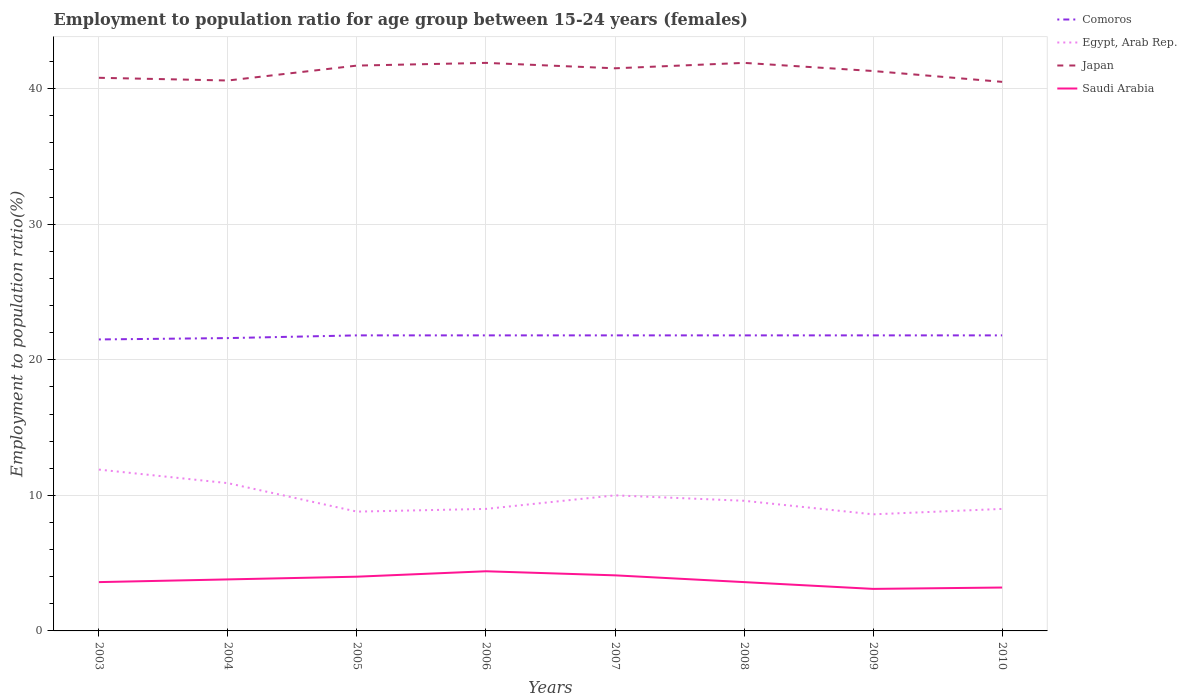Is the number of lines equal to the number of legend labels?
Your answer should be very brief. Yes. Across all years, what is the maximum employment to population ratio in Egypt, Arab Rep.?
Keep it short and to the point. 8.6. In which year was the employment to population ratio in Comoros maximum?
Your response must be concise. 2003. What is the difference between the highest and the second highest employment to population ratio in Egypt, Arab Rep.?
Keep it short and to the point. 3.3. What is the difference between the highest and the lowest employment to population ratio in Saudi Arabia?
Provide a short and direct response. 4. Is the employment to population ratio in Saudi Arabia strictly greater than the employment to population ratio in Japan over the years?
Offer a very short reply. Yes. How many lines are there?
Your response must be concise. 4. Does the graph contain any zero values?
Offer a very short reply. No. How many legend labels are there?
Your answer should be compact. 4. What is the title of the graph?
Your answer should be compact. Employment to population ratio for age group between 15-24 years (females). What is the Employment to population ratio(%) in Comoros in 2003?
Keep it short and to the point. 21.5. What is the Employment to population ratio(%) in Egypt, Arab Rep. in 2003?
Make the answer very short. 11.9. What is the Employment to population ratio(%) in Japan in 2003?
Your answer should be compact. 40.8. What is the Employment to population ratio(%) in Saudi Arabia in 2003?
Keep it short and to the point. 3.6. What is the Employment to population ratio(%) in Comoros in 2004?
Keep it short and to the point. 21.6. What is the Employment to population ratio(%) of Egypt, Arab Rep. in 2004?
Offer a terse response. 10.9. What is the Employment to population ratio(%) in Japan in 2004?
Offer a very short reply. 40.6. What is the Employment to population ratio(%) in Saudi Arabia in 2004?
Provide a short and direct response. 3.8. What is the Employment to population ratio(%) of Comoros in 2005?
Offer a very short reply. 21.8. What is the Employment to population ratio(%) of Egypt, Arab Rep. in 2005?
Give a very brief answer. 8.8. What is the Employment to population ratio(%) of Japan in 2005?
Ensure brevity in your answer.  41.7. What is the Employment to population ratio(%) in Comoros in 2006?
Keep it short and to the point. 21.8. What is the Employment to population ratio(%) in Egypt, Arab Rep. in 2006?
Offer a very short reply. 9. What is the Employment to population ratio(%) in Japan in 2006?
Your response must be concise. 41.9. What is the Employment to population ratio(%) of Saudi Arabia in 2006?
Offer a terse response. 4.4. What is the Employment to population ratio(%) of Comoros in 2007?
Keep it short and to the point. 21.8. What is the Employment to population ratio(%) in Japan in 2007?
Keep it short and to the point. 41.5. What is the Employment to population ratio(%) in Saudi Arabia in 2007?
Your answer should be very brief. 4.1. What is the Employment to population ratio(%) of Comoros in 2008?
Your answer should be very brief. 21.8. What is the Employment to population ratio(%) of Egypt, Arab Rep. in 2008?
Offer a very short reply. 9.6. What is the Employment to population ratio(%) in Japan in 2008?
Your answer should be compact. 41.9. What is the Employment to population ratio(%) of Saudi Arabia in 2008?
Give a very brief answer. 3.6. What is the Employment to population ratio(%) of Comoros in 2009?
Provide a short and direct response. 21.8. What is the Employment to population ratio(%) of Egypt, Arab Rep. in 2009?
Offer a very short reply. 8.6. What is the Employment to population ratio(%) of Japan in 2009?
Offer a very short reply. 41.3. What is the Employment to population ratio(%) in Saudi Arabia in 2009?
Keep it short and to the point. 3.1. What is the Employment to population ratio(%) of Comoros in 2010?
Your response must be concise. 21.8. What is the Employment to population ratio(%) of Japan in 2010?
Offer a very short reply. 40.5. What is the Employment to population ratio(%) of Saudi Arabia in 2010?
Offer a very short reply. 3.2. Across all years, what is the maximum Employment to population ratio(%) in Comoros?
Your response must be concise. 21.8. Across all years, what is the maximum Employment to population ratio(%) in Egypt, Arab Rep.?
Provide a succinct answer. 11.9. Across all years, what is the maximum Employment to population ratio(%) in Japan?
Provide a short and direct response. 41.9. Across all years, what is the maximum Employment to population ratio(%) in Saudi Arabia?
Offer a very short reply. 4.4. Across all years, what is the minimum Employment to population ratio(%) in Comoros?
Offer a very short reply. 21.5. Across all years, what is the minimum Employment to population ratio(%) of Egypt, Arab Rep.?
Provide a succinct answer. 8.6. Across all years, what is the minimum Employment to population ratio(%) of Japan?
Your response must be concise. 40.5. Across all years, what is the minimum Employment to population ratio(%) of Saudi Arabia?
Ensure brevity in your answer.  3.1. What is the total Employment to population ratio(%) in Comoros in the graph?
Provide a succinct answer. 173.9. What is the total Employment to population ratio(%) in Egypt, Arab Rep. in the graph?
Offer a terse response. 77.8. What is the total Employment to population ratio(%) in Japan in the graph?
Give a very brief answer. 330.2. What is the total Employment to population ratio(%) of Saudi Arabia in the graph?
Offer a terse response. 29.8. What is the difference between the Employment to population ratio(%) of Comoros in 2003 and that in 2004?
Offer a terse response. -0.1. What is the difference between the Employment to population ratio(%) of Japan in 2003 and that in 2004?
Offer a very short reply. 0.2. What is the difference between the Employment to population ratio(%) of Saudi Arabia in 2003 and that in 2004?
Ensure brevity in your answer.  -0.2. What is the difference between the Employment to population ratio(%) in Comoros in 2003 and that in 2006?
Your response must be concise. -0.3. What is the difference between the Employment to population ratio(%) in Saudi Arabia in 2003 and that in 2006?
Provide a succinct answer. -0.8. What is the difference between the Employment to population ratio(%) of Comoros in 2003 and that in 2007?
Keep it short and to the point. -0.3. What is the difference between the Employment to population ratio(%) of Egypt, Arab Rep. in 2003 and that in 2007?
Give a very brief answer. 1.9. What is the difference between the Employment to population ratio(%) of Saudi Arabia in 2003 and that in 2007?
Provide a succinct answer. -0.5. What is the difference between the Employment to population ratio(%) of Comoros in 2003 and that in 2008?
Your answer should be compact. -0.3. What is the difference between the Employment to population ratio(%) in Egypt, Arab Rep. in 2003 and that in 2008?
Ensure brevity in your answer.  2.3. What is the difference between the Employment to population ratio(%) in Japan in 2003 and that in 2010?
Your response must be concise. 0.3. What is the difference between the Employment to population ratio(%) in Saudi Arabia in 2003 and that in 2010?
Provide a short and direct response. 0.4. What is the difference between the Employment to population ratio(%) in Japan in 2004 and that in 2005?
Your answer should be compact. -1.1. What is the difference between the Employment to population ratio(%) of Comoros in 2004 and that in 2006?
Keep it short and to the point. -0.2. What is the difference between the Employment to population ratio(%) of Egypt, Arab Rep. in 2004 and that in 2006?
Provide a short and direct response. 1.9. What is the difference between the Employment to population ratio(%) in Japan in 2004 and that in 2006?
Provide a succinct answer. -1.3. What is the difference between the Employment to population ratio(%) of Comoros in 2004 and that in 2008?
Provide a short and direct response. -0.2. What is the difference between the Employment to population ratio(%) in Saudi Arabia in 2004 and that in 2008?
Make the answer very short. 0.2. What is the difference between the Employment to population ratio(%) in Comoros in 2004 and that in 2009?
Your response must be concise. -0.2. What is the difference between the Employment to population ratio(%) in Japan in 2004 and that in 2009?
Your response must be concise. -0.7. What is the difference between the Employment to population ratio(%) in Saudi Arabia in 2004 and that in 2009?
Your answer should be compact. 0.7. What is the difference between the Employment to population ratio(%) of Egypt, Arab Rep. in 2004 and that in 2010?
Give a very brief answer. 1.9. What is the difference between the Employment to population ratio(%) in Japan in 2004 and that in 2010?
Ensure brevity in your answer.  0.1. What is the difference between the Employment to population ratio(%) in Saudi Arabia in 2004 and that in 2010?
Provide a short and direct response. 0.6. What is the difference between the Employment to population ratio(%) in Egypt, Arab Rep. in 2005 and that in 2006?
Give a very brief answer. -0.2. What is the difference between the Employment to population ratio(%) of Japan in 2005 and that in 2006?
Make the answer very short. -0.2. What is the difference between the Employment to population ratio(%) of Japan in 2005 and that in 2007?
Keep it short and to the point. 0.2. What is the difference between the Employment to population ratio(%) of Comoros in 2005 and that in 2008?
Give a very brief answer. 0. What is the difference between the Employment to population ratio(%) in Egypt, Arab Rep. in 2005 and that in 2008?
Keep it short and to the point. -0.8. What is the difference between the Employment to population ratio(%) of Comoros in 2005 and that in 2009?
Keep it short and to the point. 0. What is the difference between the Employment to population ratio(%) of Saudi Arabia in 2005 and that in 2009?
Your answer should be compact. 0.9. What is the difference between the Employment to population ratio(%) in Comoros in 2005 and that in 2010?
Your response must be concise. 0. What is the difference between the Employment to population ratio(%) of Egypt, Arab Rep. in 2005 and that in 2010?
Make the answer very short. -0.2. What is the difference between the Employment to population ratio(%) of Japan in 2005 and that in 2010?
Offer a terse response. 1.2. What is the difference between the Employment to population ratio(%) in Japan in 2006 and that in 2007?
Provide a short and direct response. 0.4. What is the difference between the Employment to population ratio(%) of Saudi Arabia in 2006 and that in 2007?
Make the answer very short. 0.3. What is the difference between the Employment to population ratio(%) of Saudi Arabia in 2006 and that in 2008?
Give a very brief answer. 0.8. What is the difference between the Employment to population ratio(%) of Egypt, Arab Rep. in 2006 and that in 2010?
Give a very brief answer. 0. What is the difference between the Employment to population ratio(%) in Comoros in 2007 and that in 2008?
Keep it short and to the point. 0. What is the difference between the Employment to population ratio(%) in Egypt, Arab Rep. in 2007 and that in 2008?
Your response must be concise. 0.4. What is the difference between the Employment to population ratio(%) of Egypt, Arab Rep. in 2007 and that in 2009?
Offer a very short reply. 1.4. What is the difference between the Employment to population ratio(%) of Saudi Arabia in 2007 and that in 2009?
Keep it short and to the point. 1. What is the difference between the Employment to population ratio(%) of Japan in 2007 and that in 2010?
Make the answer very short. 1. What is the difference between the Employment to population ratio(%) in Comoros in 2008 and that in 2009?
Keep it short and to the point. 0. What is the difference between the Employment to population ratio(%) of Saudi Arabia in 2008 and that in 2009?
Keep it short and to the point. 0.5. What is the difference between the Employment to population ratio(%) of Comoros in 2008 and that in 2010?
Provide a succinct answer. 0. What is the difference between the Employment to population ratio(%) in Egypt, Arab Rep. in 2009 and that in 2010?
Your answer should be very brief. -0.4. What is the difference between the Employment to population ratio(%) of Japan in 2009 and that in 2010?
Your answer should be very brief. 0.8. What is the difference between the Employment to population ratio(%) of Comoros in 2003 and the Employment to population ratio(%) of Egypt, Arab Rep. in 2004?
Ensure brevity in your answer.  10.6. What is the difference between the Employment to population ratio(%) in Comoros in 2003 and the Employment to population ratio(%) in Japan in 2004?
Offer a terse response. -19.1. What is the difference between the Employment to population ratio(%) of Egypt, Arab Rep. in 2003 and the Employment to population ratio(%) of Japan in 2004?
Keep it short and to the point. -28.7. What is the difference between the Employment to population ratio(%) in Comoros in 2003 and the Employment to population ratio(%) in Egypt, Arab Rep. in 2005?
Your response must be concise. 12.7. What is the difference between the Employment to population ratio(%) of Comoros in 2003 and the Employment to population ratio(%) of Japan in 2005?
Keep it short and to the point. -20.2. What is the difference between the Employment to population ratio(%) in Egypt, Arab Rep. in 2003 and the Employment to population ratio(%) in Japan in 2005?
Keep it short and to the point. -29.8. What is the difference between the Employment to population ratio(%) of Japan in 2003 and the Employment to population ratio(%) of Saudi Arabia in 2005?
Make the answer very short. 36.8. What is the difference between the Employment to population ratio(%) of Comoros in 2003 and the Employment to population ratio(%) of Japan in 2006?
Provide a succinct answer. -20.4. What is the difference between the Employment to population ratio(%) in Japan in 2003 and the Employment to population ratio(%) in Saudi Arabia in 2006?
Your answer should be very brief. 36.4. What is the difference between the Employment to population ratio(%) of Comoros in 2003 and the Employment to population ratio(%) of Egypt, Arab Rep. in 2007?
Keep it short and to the point. 11.5. What is the difference between the Employment to population ratio(%) of Comoros in 2003 and the Employment to population ratio(%) of Japan in 2007?
Give a very brief answer. -20. What is the difference between the Employment to population ratio(%) of Egypt, Arab Rep. in 2003 and the Employment to population ratio(%) of Japan in 2007?
Provide a succinct answer. -29.6. What is the difference between the Employment to population ratio(%) in Egypt, Arab Rep. in 2003 and the Employment to population ratio(%) in Saudi Arabia in 2007?
Ensure brevity in your answer.  7.8. What is the difference between the Employment to population ratio(%) in Japan in 2003 and the Employment to population ratio(%) in Saudi Arabia in 2007?
Ensure brevity in your answer.  36.7. What is the difference between the Employment to population ratio(%) in Comoros in 2003 and the Employment to population ratio(%) in Japan in 2008?
Keep it short and to the point. -20.4. What is the difference between the Employment to population ratio(%) of Egypt, Arab Rep. in 2003 and the Employment to population ratio(%) of Japan in 2008?
Ensure brevity in your answer.  -30. What is the difference between the Employment to population ratio(%) of Japan in 2003 and the Employment to population ratio(%) of Saudi Arabia in 2008?
Your answer should be very brief. 37.2. What is the difference between the Employment to population ratio(%) of Comoros in 2003 and the Employment to population ratio(%) of Egypt, Arab Rep. in 2009?
Ensure brevity in your answer.  12.9. What is the difference between the Employment to population ratio(%) of Comoros in 2003 and the Employment to population ratio(%) of Japan in 2009?
Offer a very short reply. -19.8. What is the difference between the Employment to population ratio(%) of Egypt, Arab Rep. in 2003 and the Employment to population ratio(%) of Japan in 2009?
Your answer should be compact. -29.4. What is the difference between the Employment to population ratio(%) of Japan in 2003 and the Employment to population ratio(%) of Saudi Arabia in 2009?
Your response must be concise. 37.7. What is the difference between the Employment to population ratio(%) in Comoros in 2003 and the Employment to population ratio(%) in Egypt, Arab Rep. in 2010?
Provide a succinct answer. 12.5. What is the difference between the Employment to population ratio(%) of Comoros in 2003 and the Employment to population ratio(%) of Japan in 2010?
Keep it short and to the point. -19. What is the difference between the Employment to population ratio(%) of Comoros in 2003 and the Employment to population ratio(%) of Saudi Arabia in 2010?
Ensure brevity in your answer.  18.3. What is the difference between the Employment to population ratio(%) of Egypt, Arab Rep. in 2003 and the Employment to population ratio(%) of Japan in 2010?
Your answer should be compact. -28.6. What is the difference between the Employment to population ratio(%) in Japan in 2003 and the Employment to population ratio(%) in Saudi Arabia in 2010?
Your response must be concise. 37.6. What is the difference between the Employment to population ratio(%) of Comoros in 2004 and the Employment to population ratio(%) of Japan in 2005?
Keep it short and to the point. -20.1. What is the difference between the Employment to population ratio(%) of Egypt, Arab Rep. in 2004 and the Employment to population ratio(%) of Japan in 2005?
Keep it short and to the point. -30.8. What is the difference between the Employment to population ratio(%) of Egypt, Arab Rep. in 2004 and the Employment to population ratio(%) of Saudi Arabia in 2005?
Offer a very short reply. 6.9. What is the difference between the Employment to population ratio(%) in Japan in 2004 and the Employment to population ratio(%) in Saudi Arabia in 2005?
Give a very brief answer. 36.6. What is the difference between the Employment to population ratio(%) of Comoros in 2004 and the Employment to population ratio(%) of Japan in 2006?
Ensure brevity in your answer.  -20.3. What is the difference between the Employment to population ratio(%) of Comoros in 2004 and the Employment to population ratio(%) of Saudi Arabia in 2006?
Your response must be concise. 17.2. What is the difference between the Employment to population ratio(%) in Egypt, Arab Rep. in 2004 and the Employment to population ratio(%) in Japan in 2006?
Provide a succinct answer. -31. What is the difference between the Employment to population ratio(%) in Egypt, Arab Rep. in 2004 and the Employment to population ratio(%) in Saudi Arabia in 2006?
Provide a succinct answer. 6.5. What is the difference between the Employment to population ratio(%) of Japan in 2004 and the Employment to population ratio(%) of Saudi Arabia in 2006?
Keep it short and to the point. 36.2. What is the difference between the Employment to population ratio(%) in Comoros in 2004 and the Employment to population ratio(%) in Egypt, Arab Rep. in 2007?
Make the answer very short. 11.6. What is the difference between the Employment to population ratio(%) in Comoros in 2004 and the Employment to population ratio(%) in Japan in 2007?
Give a very brief answer. -19.9. What is the difference between the Employment to population ratio(%) in Egypt, Arab Rep. in 2004 and the Employment to population ratio(%) in Japan in 2007?
Your response must be concise. -30.6. What is the difference between the Employment to population ratio(%) of Japan in 2004 and the Employment to population ratio(%) of Saudi Arabia in 2007?
Offer a very short reply. 36.5. What is the difference between the Employment to population ratio(%) of Comoros in 2004 and the Employment to population ratio(%) of Japan in 2008?
Offer a very short reply. -20.3. What is the difference between the Employment to population ratio(%) of Egypt, Arab Rep. in 2004 and the Employment to population ratio(%) of Japan in 2008?
Provide a short and direct response. -31. What is the difference between the Employment to population ratio(%) of Egypt, Arab Rep. in 2004 and the Employment to population ratio(%) of Saudi Arabia in 2008?
Provide a short and direct response. 7.3. What is the difference between the Employment to population ratio(%) in Comoros in 2004 and the Employment to population ratio(%) in Japan in 2009?
Keep it short and to the point. -19.7. What is the difference between the Employment to population ratio(%) of Egypt, Arab Rep. in 2004 and the Employment to population ratio(%) of Japan in 2009?
Make the answer very short. -30.4. What is the difference between the Employment to population ratio(%) of Egypt, Arab Rep. in 2004 and the Employment to population ratio(%) of Saudi Arabia in 2009?
Your answer should be compact. 7.8. What is the difference between the Employment to population ratio(%) of Japan in 2004 and the Employment to population ratio(%) of Saudi Arabia in 2009?
Keep it short and to the point. 37.5. What is the difference between the Employment to population ratio(%) in Comoros in 2004 and the Employment to population ratio(%) in Egypt, Arab Rep. in 2010?
Keep it short and to the point. 12.6. What is the difference between the Employment to population ratio(%) in Comoros in 2004 and the Employment to population ratio(%) in Japan in 2010?
Keep it short and to the point. -18.9. What is the difference between the Employment to population ratio(%) of Comoros in 2004 and the Employment to population ratio(%) of Saudi Arabia in 2010?
Offer a very short reply. 18.4. What is the difference between the Employment to population ratio(%) in Egypt, Arab Rep. in 2004 and the Employment to population ratio(%) in Japan in 2010?
Give a very brief answer. -29.6. What is the difference between the Employment to population ratio(%) of Japan in 2004 and the Employment to population ratio(%) of Saudi Arabia in 2010?
Keep it short and to the point. 37.4. What is the difference between the Employment to population ratio(%) in Comoros in 2005 and the Employment to population ratio(%) in Egypt, Arab Rep. in 2006?
Make the answer very short. 12.8. What is the difference between the Employment to population ratio(%) in Comoros in 2005 and the Employment to population ratio(%) in Japan in 2006?
Your answer should be compact. -20.1. What is the difference between the Employment to population ratio(%) in Comoros in 2005 and the Employment to population ratio(%) in Saudi Arabia in 2006?
Provide a short and direct response. 17.4. What is the difference between the Employment to population ratio(%) of Egypt, Arab Rep. in 2005 and the Employment to population ratio(%) of Japan in 2006?
Offer a terse response. -33.1. What is the difference between the Employment to population ratio(%) of Egypt, Arab Rep. in 2005 and the Employment to population ratio(%) of Saudi Arabia in 2006?
Give a very brief answer. 4.4. What is the difference between the Employment to population ratio(%) in Japan in 2005 and the Employment to population ratio(%) in Saudi Arabia in 2006?
Offer a terse response. 37.3. What is the difference between the Employment to population ratio(%) of Comoros in 2005 and the Employment to population ratio(%) of Egypt, Arab Rep. in 2007?
Make the answer very short. 11.8. What is the difference between the Employment to population ratio(%) in Comoros in 2005 and the Employment to population ratio(%) in Japan in 2007?
Offer a very short reply. -19.7. What is the difference between the Employment to population ratio(%) of Egypt, Arab Rep. in 2005 and the Employment to population ratio(%) of Japan in 2007?
Make the answer very short. -32.7. What is the difference between the Employment to population ratio(%) of Egypt, Arab Rep. in 2005 and the Employment to population ratio(%) of Saudi Arabia in 2007?
Ensure brevity in your answer.  4.7. What is the difference between the Employment to population ratio(%) of Japan in 2005 and the Employment to population ratio(%) of Saudi Arabia in 2007?
Give a very brief answer. 37.6. What is the difference between the Employment to population ratio(%) of Comoros in 2005 and the Employment to population ratio(%) of Egypt, Arab Rep. in 2008?
Your response must be concise. 12.2. What is the difference between the Employment to population ratio(%) in Comoros in 2005 and the Employment to population ratio(%) in Japan in 2008?
Your answer should be very brief. -20.1. What is the difference between the Employment to population ratio(%) in Comoros in 2005 and the Employment to population ratio(%) in Saudi Arabia in 2008?
Offer a terse response. 18.2. What is the difference between the Employment to population ratio(%) of Egypt, Arab Rep. in 2005 and the Employment to population ratio(%) of Japan in 2008?
Provide a succinct answer. -33.1. What is the difference between the Employment to population ratio(%) in Japan in 2005 and the Employment to population ratio(%) in Saudi Arabia in 2008?
Offer a very short reply. 38.1. What is the difference between the Employment to population ratio(%) of Comoros in 2005 and the Employment to population ratio(%) of Egypt, Arab Rep. in 2009?
Your answer should be compact. 13.2. What is the difference between the Employment to population ratio(%) in Comoros in 2005 and the Employment to population ratio(%) in Japan in 2009?
Your answer should be very brief. -19.5. What is the difference between the Employment to population ratio(%) of Egypt, Arab Rep. in 2005 and the Employment to population ratio(%) of Japan in 2009?
Ensure brevity in your answer.  -32.5. What is the difference between the Employment to population ratio(%) in Egypt, Arab Rep. in 2005 and the Employment to population ratio(%) in Saudi Arabia in 2009?
Give a very brief answer. 5.7. What is the difference between the Employment to population ratio(%) in Japan in 2005 and the Employment to population ratio(%) in Saudi Arabia in 2009?
Provide a short and direct response. 38.6. What is the difference between the Employment to population ratio(%) in Comoros in 2005 and the Employment to population ratio(%) in Egypt, Arab Rep. in 2010?
Provide a succinct answer. 12.8. What is the difference between the Employment to population ratio(%) of Comoros in 2005 and the Employment to population ratio(%) of Japan in 2010?
Your answer should be compact. -18.7. What is the difference between the Employment to population ratio(%) in Egypt, Arab Rep. in 2005 and the Employment to population ratio(%) in Japan in 2010?
Make the answer very short. -31.7. What is the difference between the Employment to population ratio(%) in Egypt, Arab Rep. in 2005 and the Employment to population ratio(%) in Saudi Arabia in 2010?
Make the answer very short. 5.6. What is the difference between the Employment to population ratio(%) of Japan in 2005 and the Employment to population ratio(%) of Saudi Arabia in 2010?
Ensure brevity in your answer.  38.5. What is the difference between the Employment to population ratio(%) in Comoros in 2006 and the Employment to population ratio(%) in Japan in 2007?
Your answer should be compact. -19.7. What is the difference between the Employment to population ratio(%) of Comoros in 2006 and the Employment to population ratio(%) of Saudi Arabia in 2007?
Your answer should be very brief. 17.7. What is the difference between the Employment to population ratio(%) of Egypt, Arab Rep. in 2006 and the Employment to population ratio(%) of Japan in 2007?
Your answer should be compact. -32.5. What is the difference between the Employment to population ratio(%) in Egypt, Arab Rep. in 2006 and the Employment to population ratio(%) in Saudi Arabia in 2007?
Keep it short and to the point. 4.9. What is the difference between the Employment to population ratio(%) of Japan in 2006 and the Employment to population ratio(%) of Saudi Arabia in 2007?
Offer a very short reply. 37.8. What is the difference between the Employment to population ratio(%) of Comoros in 2006 and the Employment to population ratio(%) of Japan in 2008?
Make the answer very short. -20.1. What is the difference between the Employment to population ratio(%) in Egypt, Arab Rep. in 2006 and the Employment to population ratio(%) in Japan in 2008?
Ensure brevity in your answer.  -32.9. What is the difference between the Employment to population ratio(%) in Japan in 2006 and the Employment to population ratio(%) in Saudi Arabia in 2008?
Your answer should be very brief. 38.3. What is the difference between the Employment to population ratio(%) of Comoros in 2006 and the Employment to population ratio(%) of Egypt, Arab Rep. in 2009?
Keep it short and to the point. 13.2. What is the difference between the Employment to population ratio(%) of Comoros in 2006 and the Employment to population ratio(%) of Japan in 2009?
Ensure brevity in your answer.  -19.5. What is the difference between the Employment to population ratio(%) in Comoros in 2006 and the Employment to population ratio(%) in Saudi Arabia in 2009?
Your answer should be very brief. 18.7. What is the difference between the Employment to population ratio(%) in Egypt, Arab Rep. in 2006 and the Employment to population ratio(%) in Japan in 2009?
Your answer should be compact. -32.3. What is the difference between the Employment to population ratio(%) in Egypt, Arab Rep. in 2006 and the Employment to population ratio(%) in Saudi Arabia in 2009?
Give a very brief answer. 5.9. What is the difference between the Employment to population ratio(%) in Japan in 2006 and the Employment to population ratio(%) in Saudi Arabia in 2009?
Keep it short and to the point. 38.8. What is the difference between the Employment to population ratio(%) of Comoros in 2006 and the Employment to population ratio(%) of Japan in 2010?
Offer a very short reply. -18.7. What is the difference between the Employment to population ratio(%) in Comoros in 2006 and the Employment to population ratio(%) in Saudi Arabia in 2010?
Your response must be concise. 18.6. What is the difference between the Employment to population ratio(%) of Egypt, Arab Rep. in 2006 and the Employment to population ratio(%) of Japan in 2010?
Your response must be concise. -31.5. What is the difference between the Employment to population ratio(%) of Japan in 2006 and the Employment to population ratio(%) of Saudi Arabia in 2010?
Offer a terse response. 38.7. What is the difference between the Employment to population ratio(%) of Comoros in 2007 and the Employment to population ratio(%) of Egypt, Arab Rep. in 2008?
Ensure brevity in your answer.  12.2. What is the difference between the Employment to population ratio(%) in Comoros in 2007 and the Employment to population ratio(%) in Japan in 2008?
Provide a short and direct response. -20.1. What is the difference between the Employment to population ratio(%) in Egypt, Arab Rep. in 2007 and the Employment to population ratio(%) in Japan in 2008?
Your answer should be very brief. -31.9. What is the difference between the Employment to population ratio(%) of Egypt, Arab Rep. in 2007 and the Employment to population ratio(%) of Saudi Arabia in 2008?
Keep it short and to the point. 6.4. What is the difference between the Employment to population ratio(%) in Japan in 2007 and the Employment to population ratio(%) in Saudi Arabia in 2008?
Provide a succinct answer. 37.9. What is the difference between the Employment to population ratio(%) of Comoros in 2007 and the Employment to population ratio(%) of Japan in 2009?
Your answer should be compact. -19.5. What is the difference between the Employment to population ratio(%) of Egypt, Arab Rep. in 2007 and the Employment to population ratio(%) of Japan in 2009?
Your answer should be compact. -31.3. What is the difference between the Employment to population ratio(%) in Egypt, Arab Rep. in 2007 and the Employment to population ratio(%) in Saudi Arabia in 2009?
Give a very brief answer. 6.9. What is the difference between the Employment to population ratio(%) of Japan in 2007 and the Employment to population ratio(%) of Saudi Arabia in 2009?
Offer a very short reply. 38.4. What is the difference between the Employment to population ratio(%) of Comoros in 2007 and the Employment to population ratio(%) of Egypt, Arab Rep. in 2010?
Your response must be concise. 12.8. What is the difference between the Employment to population ratio(%) of Comoros in 2007 and the Employment to population ratio(%) of Japan in 2010?
Make the answer very short. -18.7. What is the difference between the Employment to population ratio(%) of Comoros in 2007 and the Employment to population ratio(%) of Saudi Arabia in 2010?
Provide a succinct answer. 18.6. What is the difference between the Employment to population ratio(%) in Egypt, Arab Rep. in 2007 and the Employment to population ratio(%) in Japan in 2010?
Provide a short and direct response. -30.5. What is the difference between the Employment to population ratio(%) in Japan in 2007 and the Employment to population ratio(%) in Saudi Arabia in 2010?
Ensure brevity in your answer.  38.3. What is the difference between the Employment to population ratio(%) in Comoros in 2008 and the Employment to population ratio(%) in Japan in 2009?
Your answer should be very brief. -19.5. What is the difference between the Employment to population ratio(%) of Egypt, Arab Rep. in 2008 and the Employment to population ratio(%) of Japan in 2009?
Give a very brief answer. -31.7. What is the difference between the Employment to population ratio(%) of Egypt, Arab Rep. in 2008 and the Employment to population ratio(%) of Saudi Arabia in 2009?
Give a very brief answer. 6.5. What is the difference between the Employment to population ratio(%) of Japan in 2008 and the Employment to population ratio(%) of Saudi Arabia in 2009?
Provide a short and direct response. 38.8. What is the difference between the Employment to population ratio(%) in Comoros in 2008 and the Employment to population ratio(%) in Egypt, Arab Rep. in 2010?
Ensure brevity in your answer.  12.8. What is the difference between the Employment to population ratio(%) of Comoros in 2008 and the Employment to population ratio(%) of Japan in 2010?
Your response must be concise. -18.7. What is the difference between the Employment to population ratio(%) of Comoros in 2008 and the Employment to population ratio(%) of Saudi Arabia in 2010?
Your response must be concise. 18.6. What is the difference between the Employment to population ratio(%) of Egypt, Arab Rep. in 2008 and the Employment to population ratio(%) of Japan in 2010?
Your response must be concise. -30.9. What is the difference between the Employment to population ratio(%) of Egypt, Arab Rep. in 2008 and the Employment to population ratio(%) of Saudi Arabia in 2010?
Make the answer very short. 6.4. What is the difference between the Employment to population ratio(%) of Japan in 2008 and the Employment to population ratio(%) of Saudi Arabia in 2010?
Your answer should be very brief. 38.7. What is the difference between the Employment to population ratio(%) of Comoros in 2009 and the Employment to population ratio(%) of Japan in 2010?
Keep it short and to the point. -18.7. What is the difference between the Employment to population ratio(%) in Egypt, Arab Rep. in 2009 and the Employment to population ratio(%) in Japan in 2010?
Your response must be concise. -31.9. What is the difference between the Employment to population ratio(%) of Japan in 2009 and the Employment to population ratio(%) of Saudi Arabia in 2010?
Your response must be concise. 38.1. What is the average Employment to population ratio(%) in Comoros per year?
Give a very brief answer. 21.74. What is the average Employment to population ratio(%) of Egypt, Arab Rep. per year?
Give a very brief answer. 9.72. What is the average Employment to population ratio(%) of Japan per year?
Your answer should be compact. 41.27. What is the average Employment to population ratio(%) of Saudi Arabia per year?
Your answer should be very brief. 3.73. In the year 2003, what is the difference between the Employment to population ratio(%) of Comoros and Employment to population ratio(%) of Japan?
Offer a terse response. -19.3. In the year 2003, what is the difference between the Employment to population ratio(%) of Comoros and Employment to population ratio(%) of Saudi Arabia?
Your answer should be very brief. 17.9. In the year 2003, what is the difference between the Employment to population ratio(%) in Egypt, Arab Rep. and Employment to population ratio(%) in Japan?
Provide a succinct answer. -28.9. In the year 2003, what is the difference between the Employment to population ratio(%) of Japan and Employment to population ratio(%) of Saudi Arabia?
Provide a succinct answer. 37.2. In the year 2004, what is the difference between the Employment to population ratio(%) of Comoros and Employment to population ratio(%) of Egypt, Arab Rep.?
Offer a terse response. 10.7. In the year 2004, what is the difference between the Employment to population ratio(%) of Egypt, Arab Rep. and Employment to population ratio(%) of Japan?
Your answer should be very brief. -29.7. In the year 2004, what is the difference between the Employment to population ratio(%) of Japan and Employment to population ratio(%) of Saudi Arabia?
Ensure brevity in your answer.  36.8. In the year 2005, what is the difference between the Employment to population ratio(%) of Comoros and Employment to population ratio(%) of Japan?
Keep it short and to the point. -19.9. In the year 2005, what is the difference between the Employment to population ratio(%) in Comoros and Employment to population ratio(%) in Saudi Arabia?
Provide a succinct answer. 17.8. In the year 2005, what is the difference between the Employment to population ratio(%) of Egypt, Arab Rep. and Employment to population ratio(%) of Japan?
Provide a succinct answer. -32.9. In the year 2005, what is the difference between the Employment to population ratio(%) in Japan and Employment to population ratio(%) in Saudi Arabia?
Offer a terse response. 37.7. In the year 2006, what is the difference between the Employment to population ratio(%) of Comoros and Employment to population ratio(%) of Egypt, Arab Rep.?
Your response must be concise. 12.8. In the year 2006, what is the difference between the Employment to population ratio(%) in Comoros and Employment to population ratio(%) in Japan?
Offer a very short reply. -20.1. In the year 2006, what is the difference between the Employment to population ratio(%) in Egypt, Arab Rep. and Employment to population ratio(%) in Japan?
Your answer should be very brief. -32.9. In the year 2006, what is the difference between the Employment to population ratio(%) in Japan and Employment to population ratio(%) in Saudi Arabia?
Ensure brevity in your answer.  37.5. In the year 2007, what is the difference between the Employment to population ratio(%) of Comoros and Employment to population ratio(%) of Japan?
Provide a succinct answer. -19.7. In the year 2007, what is the difference between the Employment to population ratio(%) of Comoros and Employment to population ratio(%) of Saudi Arabia?
Your answer should be very brief. 17.7. In the year 2007, what is the difference between the Employment to population ratio(%) in Egypt, Arab Rep. and Employment to population ratio(%) in Japan?
Offer a terse response. -31.5. In the year 2007, what is the difference between the Employment to population ratio(%) of Egypt, Arab Rep. and Employment to population ratio(%) of Saudi Arabia?
Give a very brief answer. 5.9. In the year 2007, what is the difference between the Employment to population ratio(%) of Japan and Employment to population ratio(%) of Saudi Arabia?
Give a very brief answer. 37.4. In the year 2008, what is the difference between the Employment to population ratio(%) in Comoros and Employment to population ratio(%) in Egypt, Arab Rep.?
Offer a terse response. 12.2. In the year 2008, what is the difference between the Employment to population ratio(%) in Comoros and Employment to population ratio(%) in Japan?
Keep it short and to the point. -20.1. In the year 2008, what is the difference between the Employment to population ratio(%) of Comoros and Employment to population ratio(%) of Saudi Arabia?
Offer a terse response. 18.2. In the year 2008, what is the difference between the Employment to population ratio(%) of Egypt, Arab Rep. and Employment to population ratio(%) of Japan?
Offer a terse response. -32.3. In the year 2008, what is the difference between the Employment to population ratio(%) of Egypt, Arab Rep. and Employment to population ratio(%) of Saudi Arabia?
Your answer should be compact. 6. In the year 2008, what is the difference between the Employment to population ratio(%) in Japan and Employment to population ratio(%) in Saudi Arabia?
Provide a short and direct response. 38.3. In the year 2009, what is the difference between the Employment to population ratio(%) in Comoros and Employment to population ratio(%) in Japan?
Provide a succinct answer. -19.5. In the year 2009, what is the difference between the Employment to population ratio(%) of Egypt, Arab Rep. and Employment to population ratio(%) of Japan?
Ensure brevity in your answer.  -32.7. In the year 2009, what is the difference between the Employment to population ratio(%) in Japan and Employment to population ratio(%) in Saudi Arabia?
Your answer should be compact. 38.2. In the year 2010, what is the difference between the Employment to population ratio(%) in Comoros and Employment to population ratio(%) in Japan?
Keep it short and to the point. -18.7. In the year 2010, what is the difference between the Employment to population ratio(%) of Egypt, Arab Rep. and Employment to population ratio(%) of Japan?
Offer a very short reply. -31.5. In the year 2010, what is the difference between the Employment to population ratio(%) in Egypt, Arab Rep. and Employment to population ratio(%) in Saudi Arabia?
Offer a terse response. 5.8. In the year 2010, what is the difference between the Employment to population ratio(%) of Japan and Employment to population ratio(%) of Saudi Arabia?
Provide a succinct answer. 37.3. What is the ratio of the Employment to population ratio(%) of Comoros in 2003 to that in 2004?
Your response must be concise. 1. What is the ratio of the Employment to population ratio(%) of Egypt, Arab Rep. in 2003 to that in 2004?
Your answer should be compact. 1.09. What is the ratio of the Employment to population ratio(%) of Japan in 2003 to that in 2004?
Your answer should be compact. 1. What is the ratio of the Employment to population ratio(%) of Comoros in 2003 to that in 2005?
Offer a very short reply. 0.99. What is the ratio of the Employment to population ratio(%) of Egypt, Arab Rep. in 2003 to that in 2005?
Your answer should be compact. 1.35. What is the ratio of the Employment to population ratio(%) in Japan in 2003 to that in 2005?
Provide a succinct answer. 0.98. What is the ratio of the Employment to population ratio(%) of Saudi Arabia in 2003 to that in 2005?
Your response must be concise. 0.9. What is the ratio of the Employment to population ratio(%) of Comoros in 2003 to that in 2006?
Offer a terse response. 0.99. What is the ratio of the Employment to population ratio(%) of Egypt, Arab Rep. in 2003 to that in 2006?
Provide a short and direct response. 1.32. What is the ratio of the Employment to population ratio(%) of Japan in 2003 to that in 2006?
Your answer should be compact. 0.97. What is the ratio of the Employment to population ratio(%) in Saudi Arabia in 2003 to that in 2006?
Give a very brief answer. 0.82. What is the ratio of the Employment to population ratio(%) in Comoros in 2003 to that in 2007?
Offer a terse response. 0.99. What is the ratio of the Employment to population ratio(%) in Egypt, Arab Rep. in 2003 to that in 2007?
Your answer should be very brief. 1.19. What is the ratio of the Employment to population ratio(%) in Japan in 2003 to that in 2007?
Your response must be concise. 0.98. What is the ratio of the Employment to population ratio(%) in Saudi Arabia in 2003 to that in 2007?
Provide a short and direct response. 0.88. What is the ratio of the Employment to population ratio(%) of Comoros in 2003 to that in 2008?
Give a very brief answer. 0.99. What is the ratio of the Employment to population ratio(%) of Egypt, Arab Rep. in 2003 to that in 2008?
Ensure brevity in your answer.  1.24. What is the ratio of the Employment to population ratio(%) of Japan in 2003 to that in 2008?
Provide a short and direct response. 0.97. What is the ratio of the Employment to population ratio(%) of Saudi Arabia in 2003 to that in 2008?
Your answer should be compact. 1. What is the ratio of the Employment to population ratio(%) of Comoros in 2003 to that in 2009?
Your answer should be compact. 0.99. What is the ratio of the Employment to population ratio(%) in Egypt, Arab Rep. in 2003 to that in 2009?
Make the answer very short. 1.38. What is the ratio of the Employment to population ratio(%) in Japan in 2003 to that in 2009?
Keep it short and to the point. 0.99. What is the ratio of the Employment to population ratio(%) in Saudi Arabia in 2003 to that in 2009?
Provide a short and direct response. 1.16. What is the ratio of the Employment to population ratio(%) of Comoros in 2003 to that in 2010?
Provide a short and direct response. 0.99. What is the ratio of the Employment to population ratio(%) in Egypt, Arab Rep. in 2003 to that in 2010?
Provide a succinct answer. 1.32. What is the ratio of the Employment to population ratio(%) in Japan in 2003 to that in 2010?
Offer a very short reply. 1.01. What is the ratio of the Employment to population ratio(%) of Saudi Arabia in 2003 to that in 2010?
Your answer should be very brief. 1.12. What is the ratio of the Employment to population ratio(%) of Egypt, Arab Rep. in 2004 to that in 2005?
Give a very brief answer. 1.24. What is the ratio of the Employment to population ratio(%) of Japan in 2004 to that in 2005?
Ensure brevity in your answer.  0.97. What is the ratio of the Employment to population ratio(%) of Egypt, Arab Rep. in 2004 to that in 2006?
Provide a short and direct response. 1.21. What is the ratio of the Employment to population ratio(%) in Japan in 2004 to that in 2006?
Provide a succinct answer. 0.97. What is the ratio of the Employment to population ratio(%) in Saudi Arabia in 2004 to that in 2006?
Provide a succinct answer. 0.86. What is the ratio of the Employment to population ratio(%) of Egypt, Arab Rep. in 2004 to that in 2007?
Your response must be concise. 1.09. What is the ratio of the Employment to population ratio(%) of Japan in 2004 to that in 2007?
Your response must be concise. 0.98. What is the ratio of the Employment to population ratio(%) in Saudi Arabia in 2004 to that in 2007?
Your answer should be compact. 0.93. What is the ratio of the Employment to population ratio(%) of Egypt, Arab Rep. in 2004 to that in 2008?
Provide a short and direct response. 1.14. What is the ratio of the Employment to population ratio(%) of Saudi Arabia in 2004 to that in 2008?
Your response must be concise. 1.06. What is the ratio of the Employment to population ratio(%) in Egypt, Arab Rep. in 2004 to that in 2009?
Give a very brief answer. 1.27. What is the ratio of the Employment to population ratio(%) in Japan in 2004 to that in 2009?
Your answer should be compact. 0.98. What is the ratio of the Employment to population ratio(%) in Saudi Arabia in 2004 to that in 2009?
Offer a terse response. 1.23. What is the ratio of the Employment to population ratio(%) in Egypt, Arab Rep. in 2004 to that in 2010?
Make the answer very short. 1.21. What is the ratio of the Employment to population ratio(%) in Japan in 2004 to that in 2010?
Your response must be concise. 1. What is the ratio of the Employment to population ratio(%) of Saudi Arabia in 2004 to that in 2010?
Ensure brevity in your answer.  1.19. What is the ratio of the Employment to population ratio(%) in Egypt, Arab Rep. in 2005 to that in 2006?
Provide a short and direct response. 0.98. What is the ratio of the Employment to population ratio(%) of Japan in 2005 to that in 2006?
Your answer should be compact. 1. What is the ratio of the Employment to population ratio(%) of Saudi Arabia in 2005 to that in 2006?
Ensure brevity in your answer.  0.91. What is the ratio of the Employment to population ratio(%) in Comoros in 2005 to that in 2007?
Give a very brief answer. 1. What is the ratio of the Employment to population ratio(%) of Saudi Arabia in 2005 to that in 2007?
Your answer should be very brief. 0.98. What is the ratio of the Employment to population ratio(%) of Comoros in 2005 to that in 2008?
Give a very brief answer. 1. What is the ratio of the Employment to population ratio(%) of Egypt, Arab Rep. in 2005 to that in 2009?
Your answer should be compact. 1.02. What is the ratio of the Employment to population ratio(%) in Japan in 2005 to that in 2009?
Your response must be concise. 1.01. What is the ratio of the Employment to population ratio(%) in Saudi Arabia in 2005 to that in 2009?
Your answer should be compact. 1.29. What is the ratio of the Employment to population ratio(%) of Comoros in 2005 to that in 2010?
Your answer should be compact. 1. What is the ratio of the Employment to population ratio(%) of Egypt, Arab Rep. in 2005 to that in 2010?
Your response must be concise. 0.98. What is the ratio of the Employment to population ratio(%) in Japan in 2005 to that in 2010?
Keep it short and to the point. 1.03. What is the ratio of the Employment to population ratio(%) of Egypt, Arab Rep. in 2006 to that in 2007?
Your response must be concise. 0.9. What is the ratio of the Employment to population ratio(%) of Japan in 2006 to that in 2007?
Provide a short and direct response. 1.01. What is the ratio of the Employment to population ratio(%) of Saudi Arabia in 2006 to that in 2007?
Provide a succinct answer. 1.07. What is the ratio of the Employment to population ratio(%) in Comoros in 2006 to that in 2008?
Provide a short and direct response. 1. What is the ratio of the Employment to population ratio(%) in Saudi Arabia in 2006 to that in 2008?
Your answer should be compact. 1.22. What is the ratio of the Employment to population ratio(%) in Egypt, Arab Rep. in 2006 to that in 2009?
Offer a terse response. 1.05. What is the ratio of the Employment to population ratio(%) of Japan in 2006 to that in 2009?
Your answer should be very brief. 1.01. What is the ratio of the Employment to population ratio(%) of Saudi Arabia in 2006 to that in 2009?
Make the answer very short. 1.42. What is the ratio of the Employment to population ratio(%) in Japan in 2006 to that in 2010?
Ensure brevity in your answer.  1.03. What is the ratio of the Employment to population ratio(%) of Saudi Arabia in 2006 to that in 2010?
Ensure brevity in your answer.  1.38. What is the ratio of the Employment to population ratio(%) in Egypt, Arab Rep. in 2007 to that in 2008?
Your response must be concise. 1.04. What is the ratio of the Employment to population ratio(%) in Saudi Arabia in 2007 to that in 2008?
Your answer should be very brief. 1.14. What is the ratio of the Employment to population ratio(%) of Egypt, Arab Rep. in 2007 to that in 2009?
Give a very brief answer. 1.16. What is the ratio of the Employment to population ratio(%) of Japan in 2007 to that in 2009?
Offer a terse response. 1. What is the ratio of the Employment to population ratio(%) in Saudi Arabia in 2007 to that in 2009?
Keep it short and to the point. 1.32. What is the ratio of the Employment to population ratio(%) in Egypt, Arab Rep. in 2007 to that in 2010?
Give a very brief answer. 1.11. What is the ratio of the Employment to population ratio(%) in Japan in 2007 to that in 2010?
Provide a succinct answer. 1.02. What is the ratio of the Employment to population ratio(%) of Saudi Arabia in 2007 to that in 2010?
Offer a very short reply. 1.28. What is the ratio of the Employment to population ratio(%) in Comoros in 2008 to that in 2009?
Make the answer very short. 1. What is the ratio of the Employment to population ratio(%) of Egypt, Arab Rep. in 2008 to that in 2009?
Your answer should be very brief. 1.12. What is the ratio of the Employment to population ratio(%) in Japan in 2008 to that in 2009?
Make the answer very short. 1.01. What is the ratio of the Employment to population ratio(%) of Saudi Arabia in 2008 to that in 2009?
Provide a succinct answer. 1.16. What is the ratio of the Employment to population ratio(%) in Egypt, Arab Rep. in 2008 to that in 2010?
Make the answer very short. 1.07. What is the ratio of the Employment to population ratio(%) of Japan in 2008 to that in 2010?
Offer a very short reply. 1.03. What is the ratio of the Employment to population ratio(%) of Saudi Arabia in 2008 to that in 2010?
Ensure brevity in your answer.  1.12. What is the ratio of the Employment to population ratio(%) in Comoros in 2009 to that in 2010?
Offer a terse response. 1. What is the ratio of the Employment to population ratio(%) of Egypt, Arab Rep. in 2009 to that in 2010?
Your answer should be very brief. 0.96. What is the ratio of the Employment to population ratio(%) of Japan in 2009 to that in 2010?
Ensure brevity in your answer.  1.02. What is the ratio of the Employment to population ratio(%) of Saudi Arabia in 2009 to that in 2010?
Give a very brief answer. 0.97. What is the difference between the highest and the second highest Employment to population ratio(%) of Comoros?
Your answer should be compact. 0. What is the difference between the highest and the second highest Employment to population ratio(%) of Egypt, Arab Rep.?
Provide a succinct answer. 1. What is the difference between the highest and the lowest Employment to population ratio(%) of Comoros?
Your answer should be very brief. 0.3. What is the difference between the highest and the lowest Employment to population ratio(%) of Egypt, Arab Rep.?
Provide a succinct answer. 3.3. What is the difference between the highest and the lowest Employment to population ratio(%) of Japan?
Make the answer very short. 1.4. 